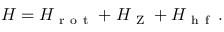<formula> <loc_0><loc_0><loc_500><loc_500>H = H _ { r o t } + H _ { Z } + H _ { h f } \, .</formula> 